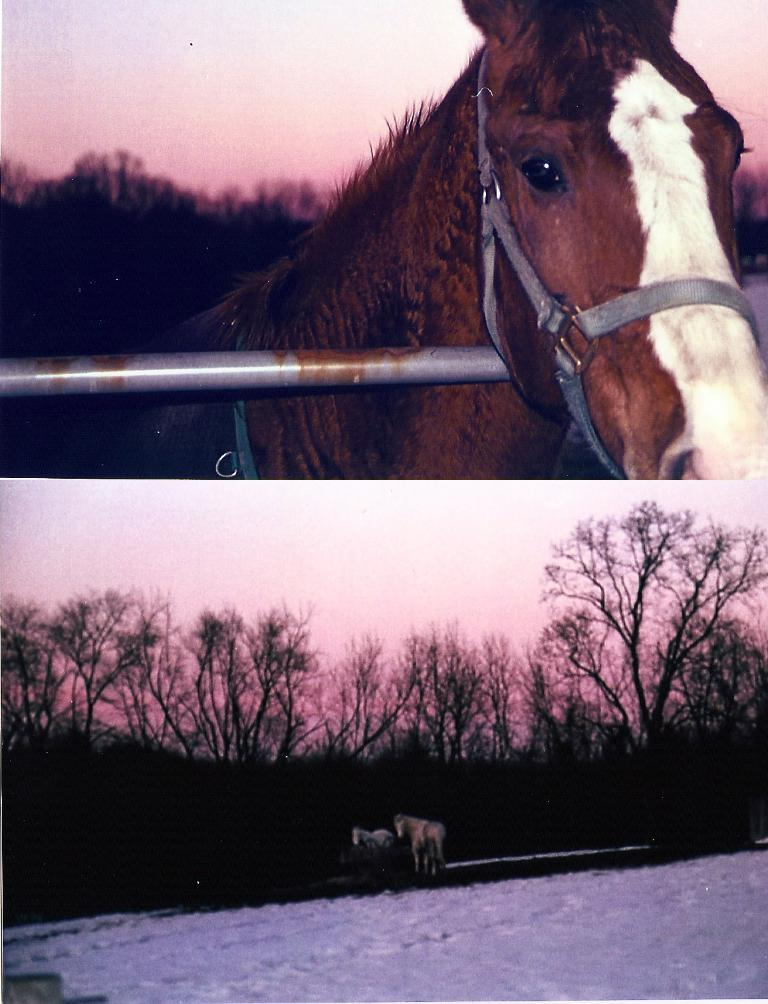What is located at the top of the image? There is a horse, a rod, trees, and sky visible at the top of the image. What is the horse's position in relation to the rod? The horse is at the top of the image, and the rod is also at the top of the image. What type of vegetation can be seen at the top and bottom of the image? Trees are visible at both the top and bottom of the image. What is the weather like in the image? The presence of snow at the bottom of the image suggests that it is a cold or snowy environment. Can you tell me how many stamps are on the horse's back in the image? There are no stamps present on the horse's back in the image. What type of part is visible on the horse's body in the image? There is no specific part of the horse's body mentioned in the image. Can you see a snail crawling on the trees at the top of the image? There is no snail present on the trees in the image. 